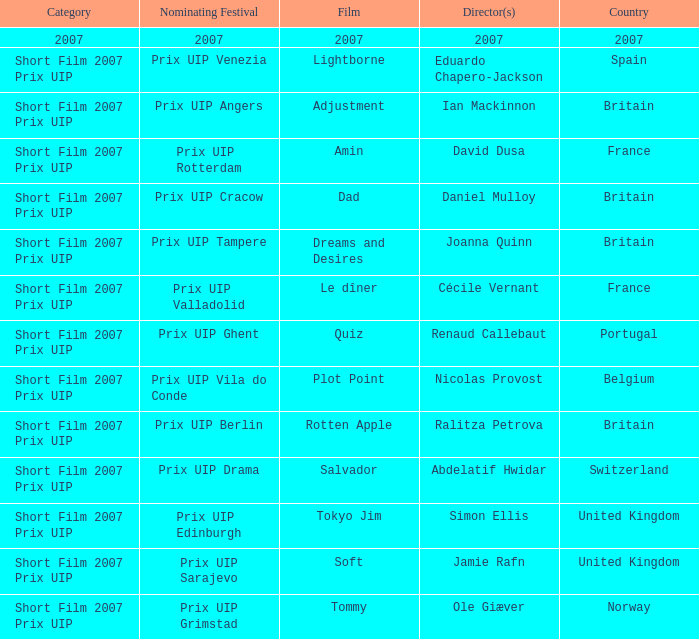What Country has a Director of 2007? 2007.0. 